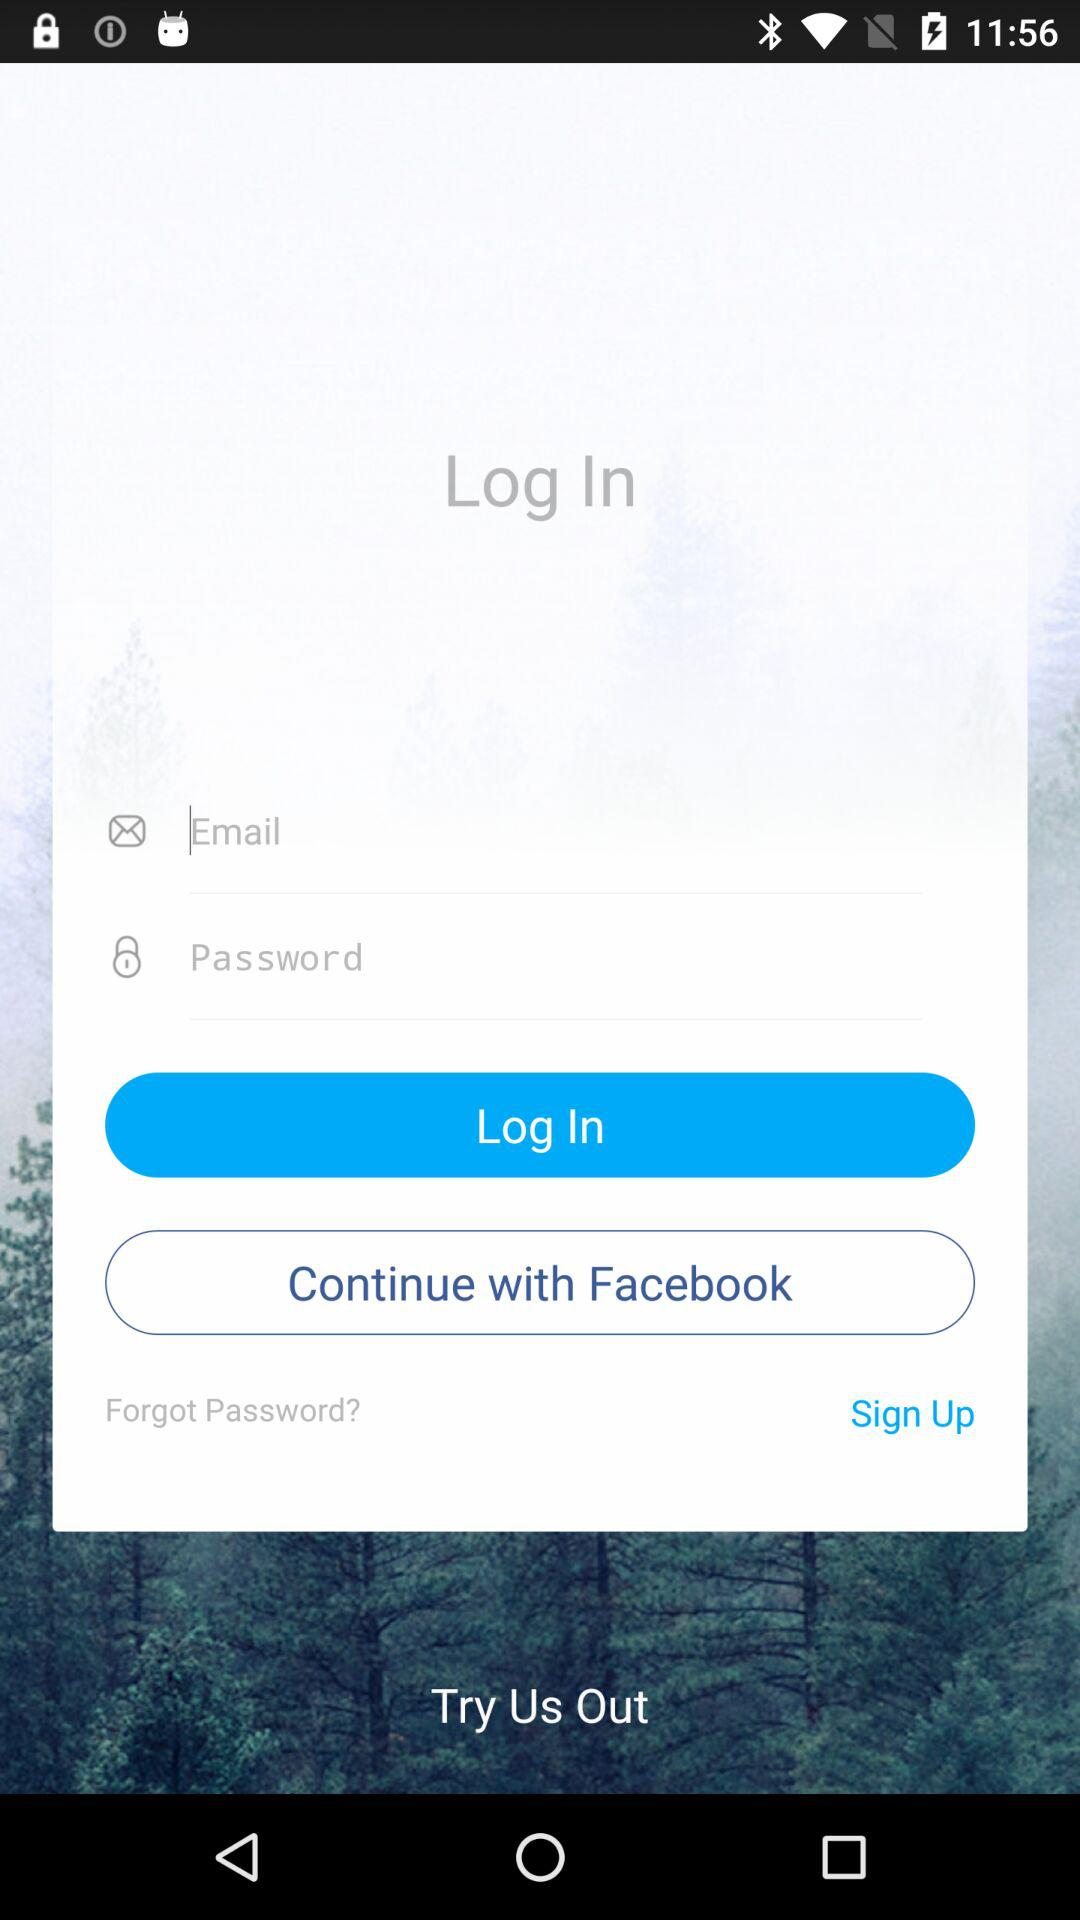Through what application can the user continue? The user can continue through "Facebook". 